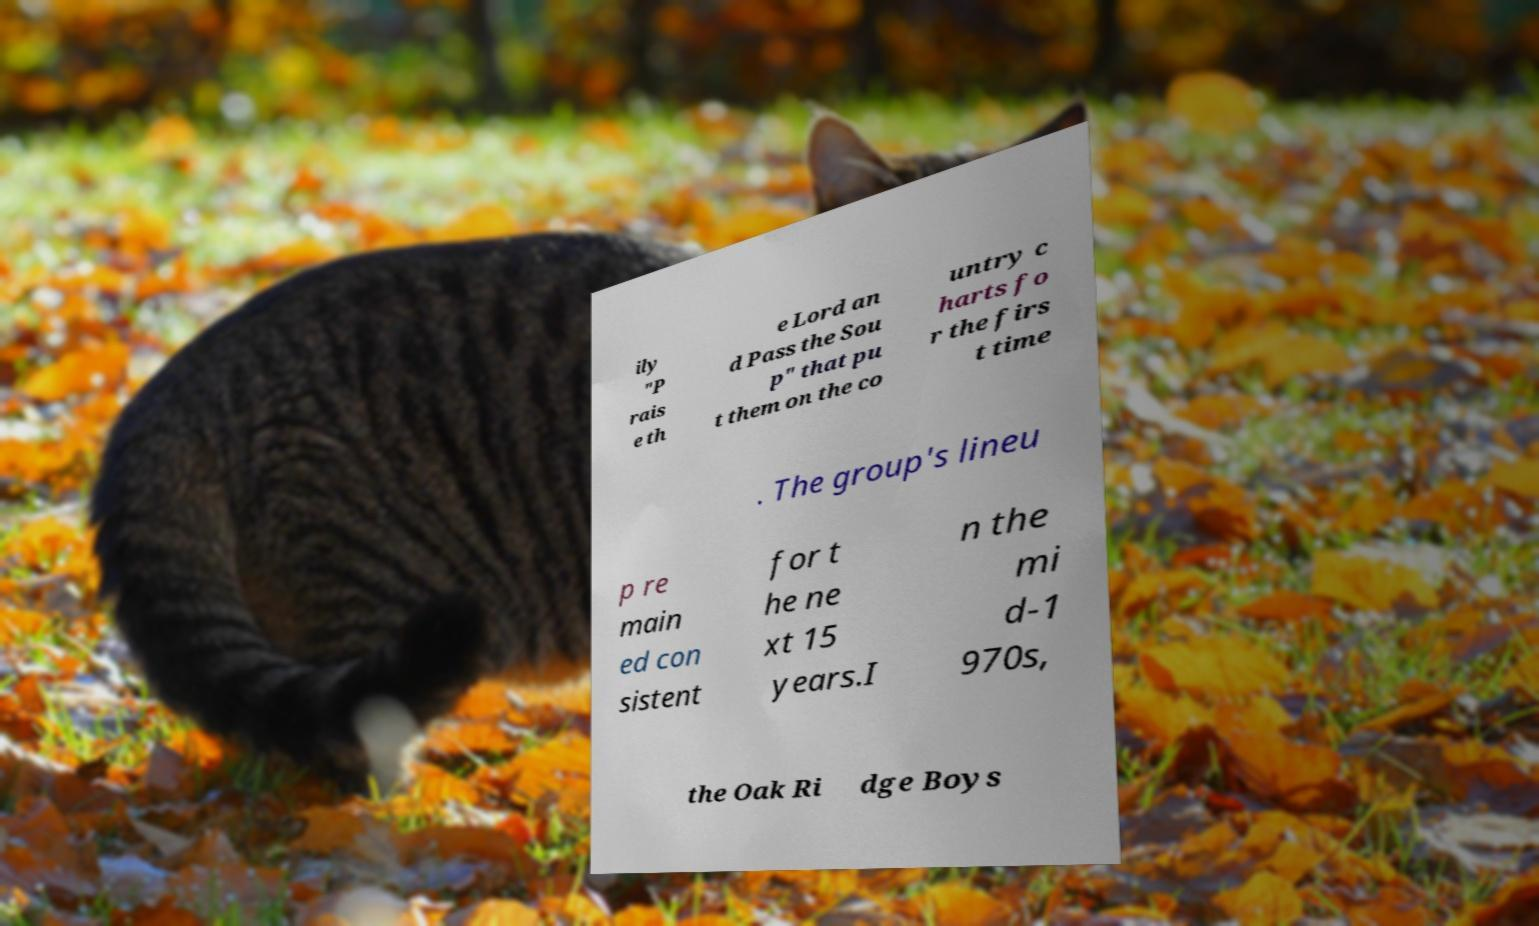There's text embedded in this image that I need extracted. Can you transcribe it verbatim? ily "P rais e th e Lord an d Pass the Sou p" that pu t them on the co untry c harts fo r the firs t time . The group's lineu p re main ed con sistent for t he ne xt 15 years.I n the mi d-1 970s, the Oak Ri dge Boys 